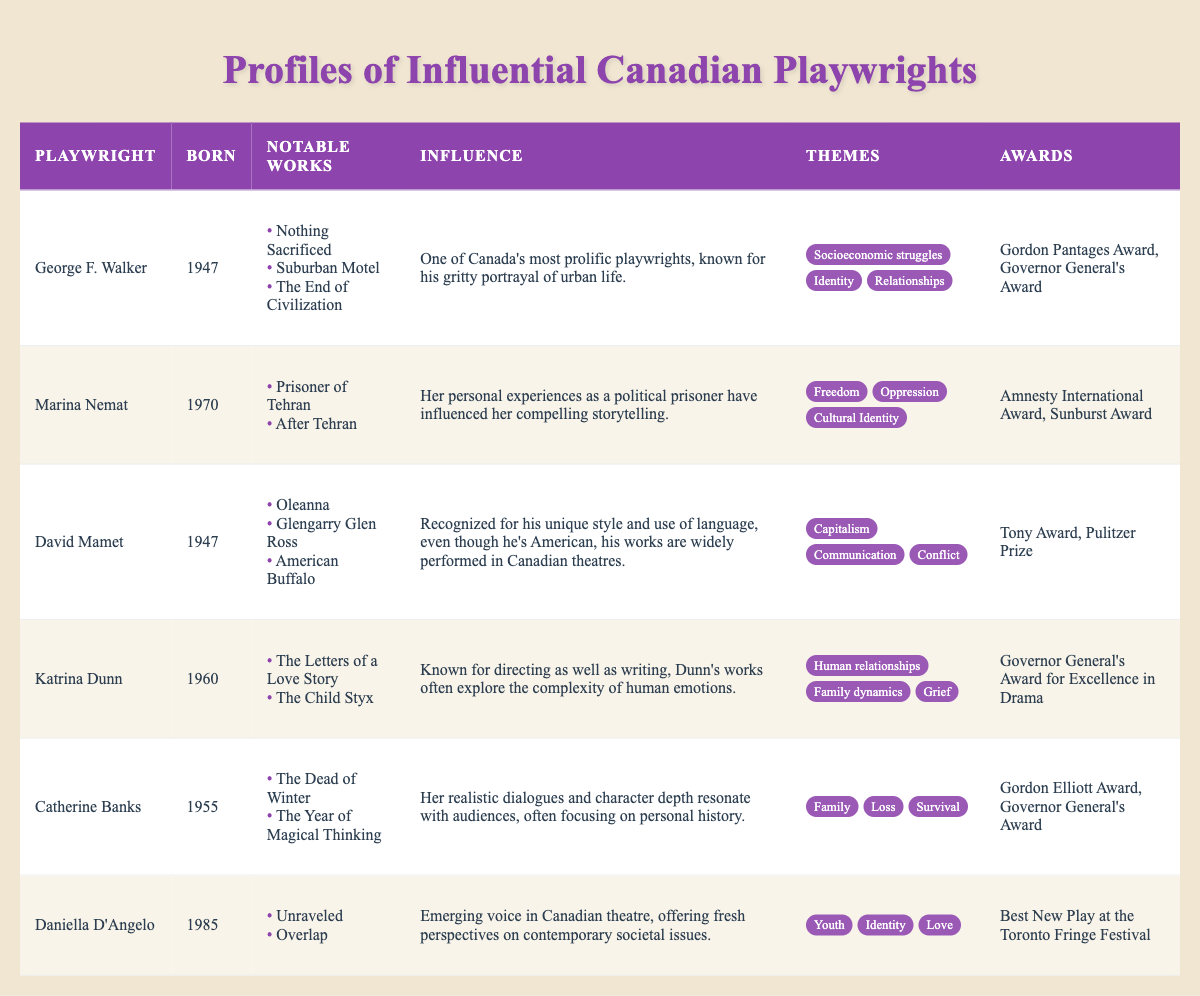What are the notable works of George F. Walker? The table lists the notable works of George F. Walker as "Nothing Sacrificed," "Suburban Motel," and "The End of Civilization."
Answer: Nothing Sacrificed, Suburban Motel, The End of Civilization Which playwright was born in 1970? By scanning the "Born" column, Marina Nemat is the only playwright listed with the year 1970.
Answer: Marina Nemat How many awards has Catherine Banks received? The table states that Catherine Banks has received two awards: the Gordon Elliott Award and the Governor General's Award.
Answer: 2 What themes are associated with Daniella D'Angelo? The table shows the themes associated with Daniella D'Angelo as "Youth," "Identity," and "Love."
Answer: Youth, Identity, Love Is George F. Walker known for portraying rural life? The influence section for George F. Walker mentions that he is known for his portrayal of urban life, which contradicts the idea of rural life.
Answer: No Are there any playwrights born in the 1960s? By reviewing the "Born" column, both George F. Walker (1947) and Katrina Dunn (1960) fall within that decade, confirming that there are playwrights from the 1960s.
Answer: Yes What is the average birth year of the listed playwrights? Summing the birth years (1947 + 1970 + 1947 + 1960 + 1955 + 1985) gives 11864, dividing by 6 total playwrights results in an average birth year of approximately 1977.
Answer: 1977 Who has won the Tony Award? The table indicates that David Mamet is the only playwright listed who has received the Tony Award.
Answer: David Mamet Which playwright’s work prominently features themes of freedom and oppression? Marina Nemat's notable works focus on the themes of "Freedom" and "Oppression," suggesting her works align with these themes.
Answer: Marina Nemat How many playwrights have won the Governor General's Award? Both George F. Walker and Catherine Banks are mentioned to have won the Governor General's Award, making a total of two playwrights.
Answer: 2 